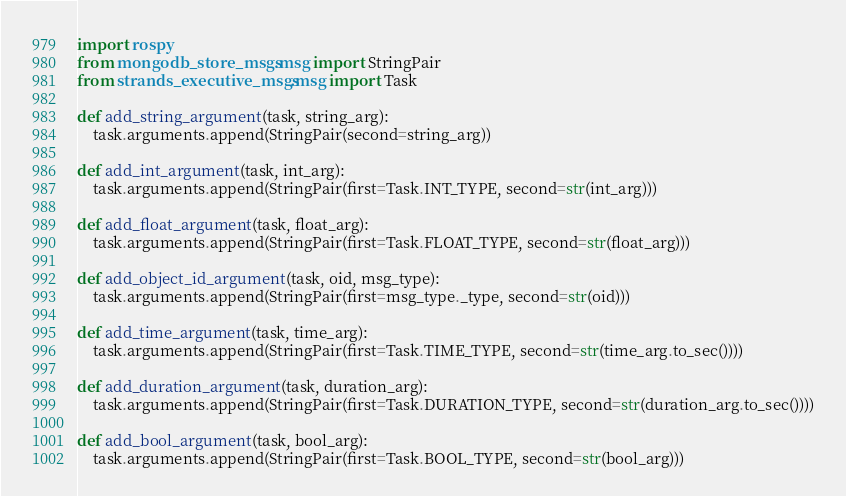<code> <loc_0><loc_0><loc_500><loc_500><_Python_>import rospy
from mongodb_store_msgs.msg import StringPair
from strands_executive_msgs.msg import Task

def add_string_argument(task, string_arg):
	task.arguments.append(StringPair(second=string_arg))

def add_int_argument(task, int_arg):
	task.arguments.append(StringPair(first=Task.INT_TYPE, second=str(int_arg)))

def add_float_argument(task, float_arg):
	task.arguments.append(StringPair(first=Task.FLOAT_TYPE, second=str(float_arg)))

def add_object_id_argument(task, oid, msg_type):
	task.arguments.append(StringPair(first=msg_type._type, second=str(oid)))

def add_time_argument(task, time_arg):
	task.arguments.append(StringPair(first=Task.TIME_TYPE, second=str(time_arg.to_sec())))

def add_duration_argument(task, duration_arg):
	task.arguments.append(StringPair(first=Task.DURATION_TYPE, second=str(duration_arg.to_sec())))

def add_bool_argument(task, bool_arg):
	task.arguments.append(StringPair(first=Task.BOOL_TYPE, second=str(bool_arg)))

</code> 